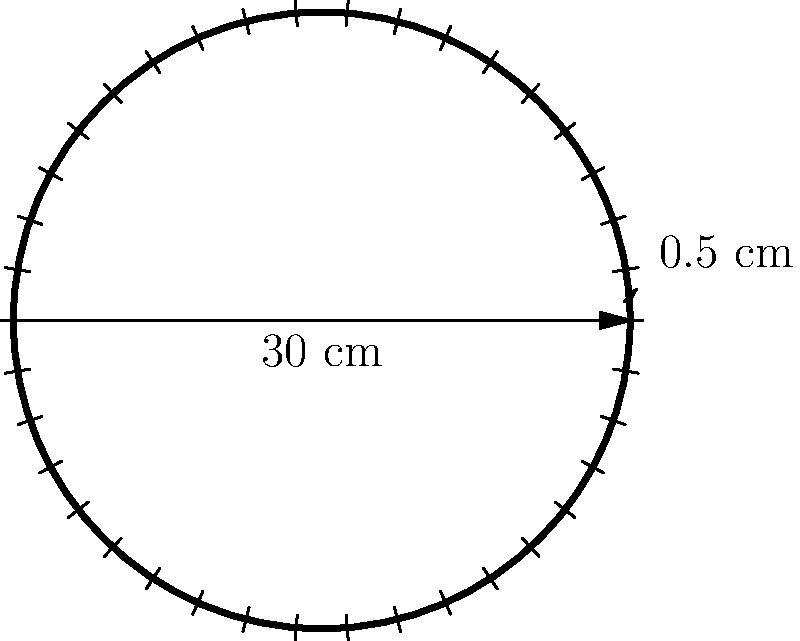As a table game supplier, you're designing a new roulette wheel. The wheel has a diameter of 30 cm and contains 38 pockets, each with a width of 0.5 cm at the outer edge. Calculate the total area of the roulette wheel, excluding the pockets. Round your answer to the nearest square centimeter. To solve this problem, we'll follow these steps:

1) First, calculate the radius of the wheel:
   $r = \frac{diameter}{2} = \frac{30 \text{ cm}}{2} = 15 \text{ cm}$

2) Calculate the total area of the wheel including pockets:
   $A_{total} = \pi r^2 = \pi (15 \text{ cm})^2 = 225\pi \text{ cm}^2$

3) Calculate the area of the pockets:
   - Circumference of the wheel: $C = 2\pi r = 2\pi(15 \text{ cm}) = 30\pi \text{ cm}$
   - Total width of pockets: $38 \times 0.5 \text{ cm} = 19 \text{ cm}$
   - Area of pockets (approximated as a rectangle):
     $A_{pockets} = 19 \text{ cm} \times 0.5 \text{ cm} = 9.5 \text{ cm}^2$

4) Subtract the area of the pockets from the total area:
   $A_{wheel} = A_{total} - A_{pockets} = 225\pi \text{ cm}^2 - 9.5 \text{ cm}^2$

5) Calculate and round to the nearest square centimeter:
   $A_{wheel} = 225\pi \text{ cm}^2 - 9.5 \text{ cm}^2 \approx 697 \text{ cm}^2$
Answer: 697 cm² 